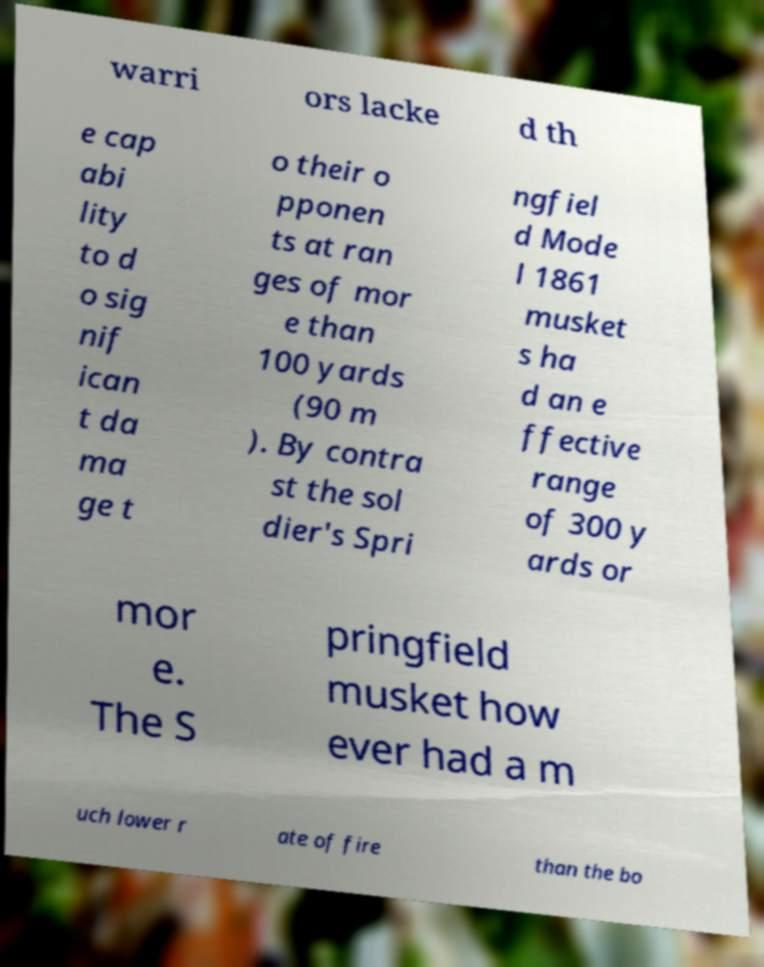For documentation purposes, I need the text within this image transcribed. Could you provide that? warri ors lacke d th e cap abi lity to d o sig nif ican t da ma ge t o their o pponen ts at ran ges of mor e than 100 yards (90 m ). By contra st the sol dier's Spri ngfiel d Mode l 1861 musket s ha d an e ffective range of 300 y ards or mor e. The S pringfield musket how ever had a m uch lower r ate of fire than the bo 